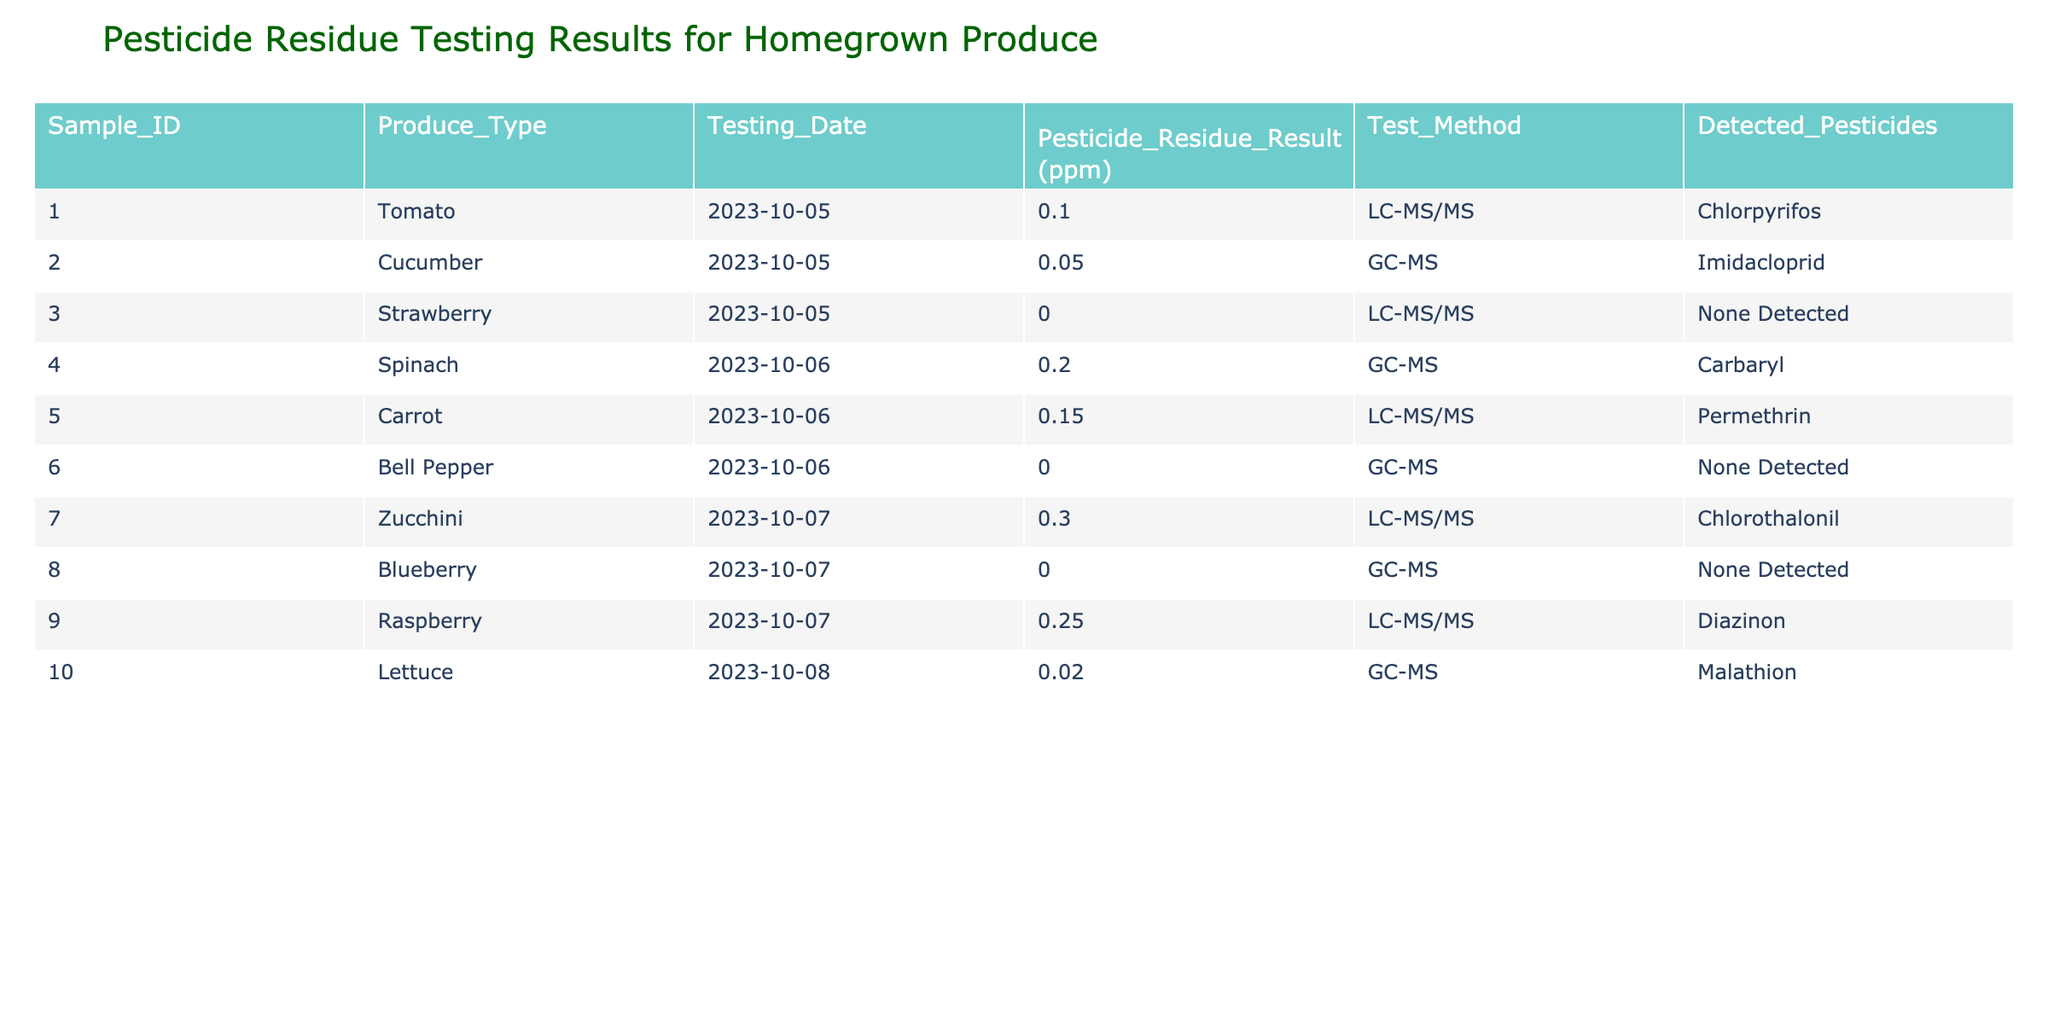What is the pesticide residue result for the cucumber sample? The cucumber sample has a pesticide residue result of 0.05 ppm, as indicated in the respective row of the table for cucumber under the "Pesticide Residue Result (ppm)" column.
Answer: 0.05 ppm Which produce type showed the highest pesticide residue level? By comparing the pesticide residue levels across all samples provided in the table, the zucchini sample records the highest level at 0.3 ppm.
Answer: Zucchini Did any of the samples show "None Detected" for pesticide residues? Yes, the strawberry, bell pepper, and blueberry samples all reported "None Detected" for pesticide residues, as shown in the "Detected Pesticides" column.
Answer: Yes What is the average pesticide residue level for the tested produce? The pesticide results (in ppm) are: 0.1, 0.05, 0, 0.2, 0.15, 0, 0.3, 0, 0.25, 0.02. Putting these together, the total residue is 0.1 + 0.05 + 0 + 0.2 + 0.15 + 0 + 0.3 + 0 + 0.25 + 0.02 = 1.07 ppm. There are 10 samples, so the average is 1.07/10 = 0.107 ppm.
Answer: 0.107 ppm Is there a produce type that has more than 0.2 ppm of pesticide residue? Yes, the zucchini sample has a residue level of 0.3 ppm, which exceeds 0.2 ppm, as referenced in the corresponding row for zucchini.
Answer: Yes Which pesticides were detected in carrot and raspberry samples? For the carrot sample, permethrin was detected with a residue level of 0.15 ppm. For the raspberry sample, diazinon was detected with a residue level of 0.25 ppm. Both can be found in the "Detected Pesticides" column next to each produce type.
Answer: Carrot: Permethrin, Raspberry: Diazinon 